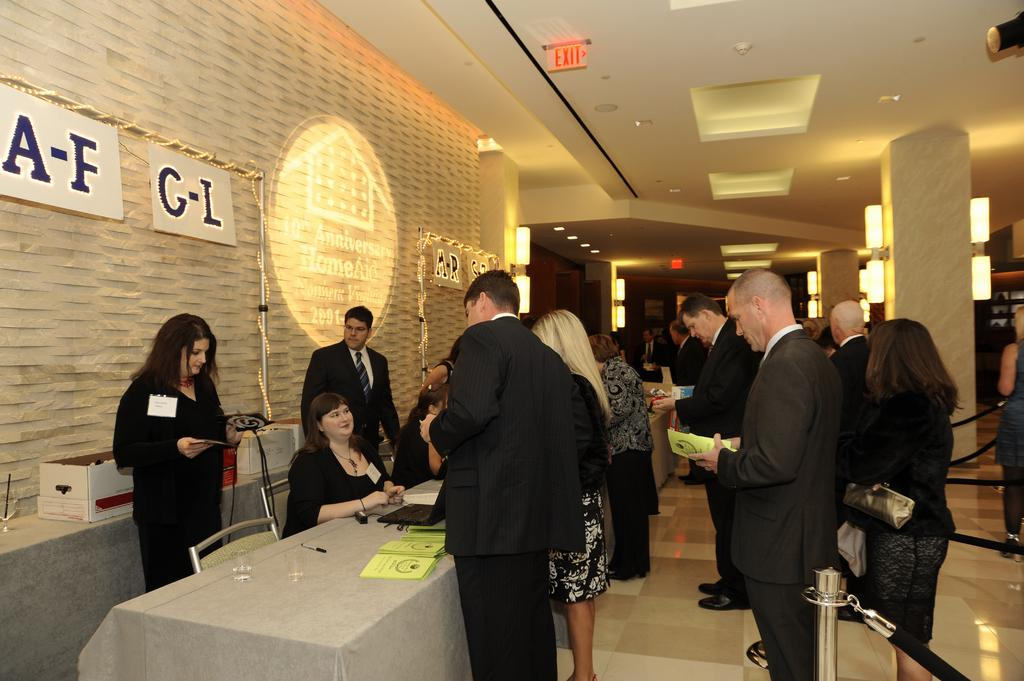What type of structure can be seen in the image? There is a wall in the image. What can be seen illuminating the area in the image? There are lights in the image. What type of furniture is present in the image? There are tables and chairs in the image. What objects are present for storage or organization? There are boxes in the image. Are there any people present in the image? Yes, there are people standing in the image. What electronic device can be seen on a table in the image? There is a laptop on a table in the image. What type of items can be seen on a table in the image? There are books on a table in the image. How many crates are being carried by the people in the image? There are no crates present in the image; only boxes are mentioned. What type of journey are the people in the image embarking on? There is no indication of a journey in the image; it simply shows people standing near tables, chairs, and other objects. 